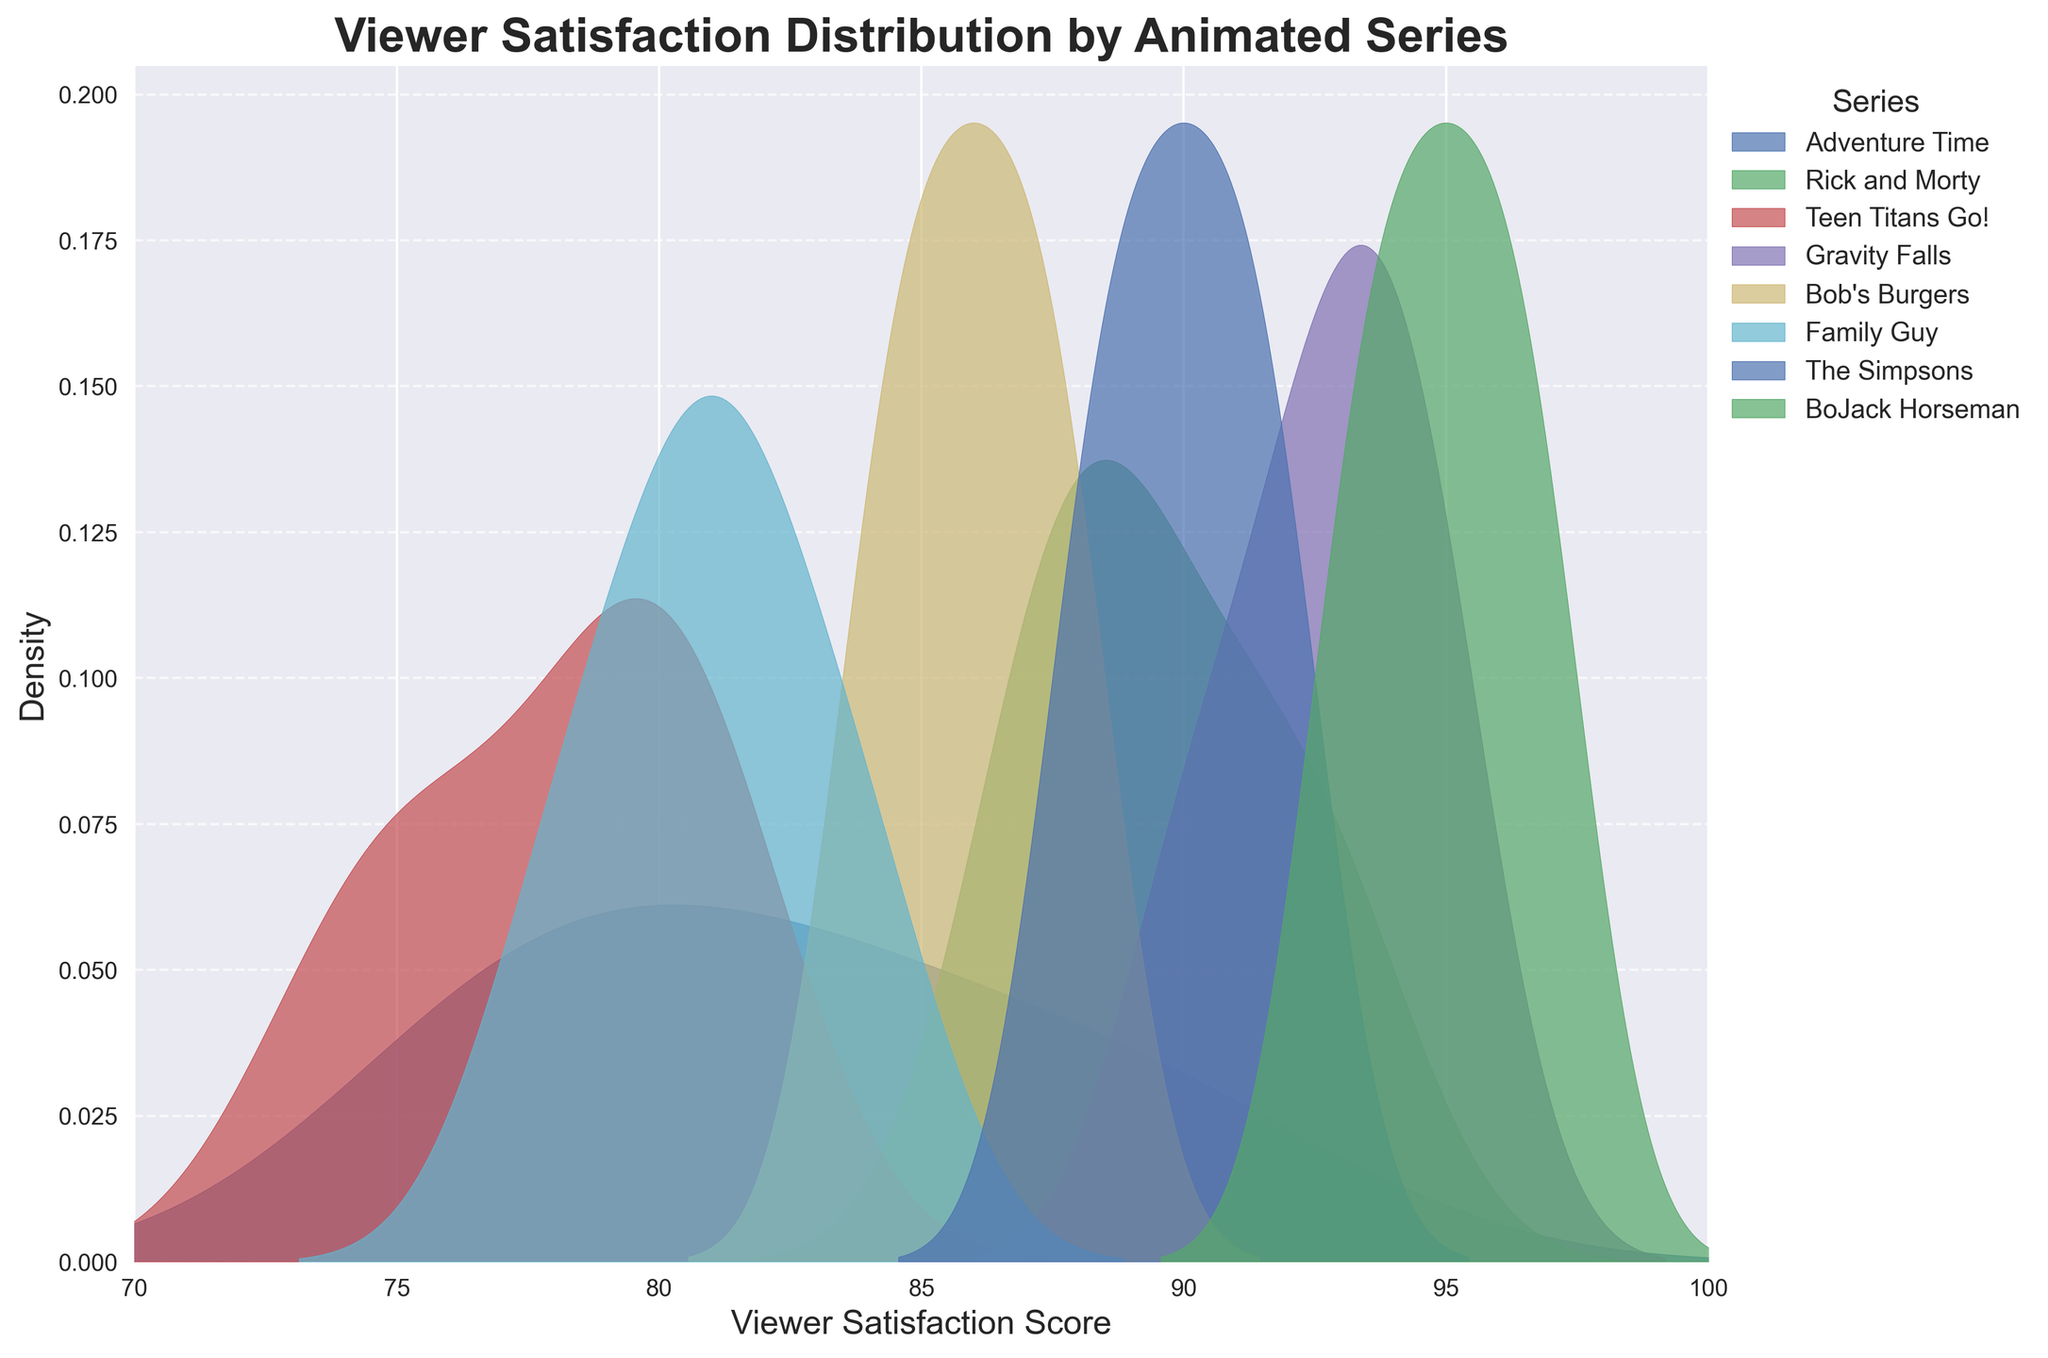What is the title of the figure? The title of the figure is prominently displayed at the top.
Answer: Viewer Satisfaction Distribution by Animated Series Which series has the highest peak density in viewer satisfaction scores? The highest peak density in the figure is indicated by the tallest curve.
Answer: BoJack Horseman At what satisfaction score does "Teen Titans Go!" show the highest density? Look at the peak position of the density curve labeled "Teen Titans Go!".
Answer: Around 79 Which series has viewer satisfaction scores primarily above 90? Identify the series whose density curve mostly lies above the score of 90 on the x-axis.
Answer: BoJack Horseman Which series appears to have the lowest overall viewer satisfaction scores? Identify the series, based on its curve, that is mostly distributed towards the lower end of the x-axis.
Answer: Teen Titans Go! Which two series have similar peak density in viewer satisfaction scores around 90? Locate the peaks of density curves that converge near the score of 90 on the x-axis.
Answer: The Simpsons and Gravity Falls How many series have their density peaks above the satisfaction score of 85? Count the number of series density curves that reach their highest points above the score of 85 on the x-axis.
Answer: Four Arrange the series from highest to lowest based on their peak satisfaction scores. Evaluate the peak positions of each series' density curve on the x-axis and order them accordingly.
Answer: BoJack Horseman, Gravity Falls, The Simpsons, Rick and Morty, Bob's Burgers, Adventure Time, Family Guy, Teen Titans Go! Which series show a significant overlap in viewer satisfaction scores between 80 and 90? Look for density curves that intersect or closely follow each other within the 80 to 90 range on the x-axis.
Answer: Adventure Time, Bob's Burgers, and Family Guy 